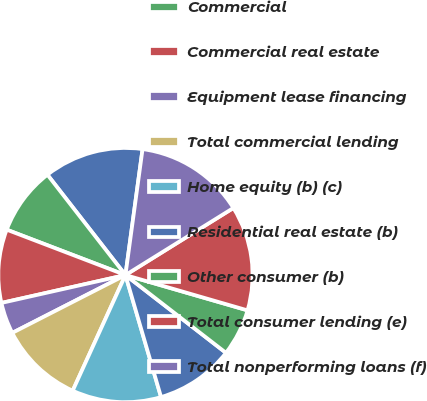Convert chart. <chart><loc_0><loc_0><loc_500><loc_500><pie_chart><fcel>December 31 - dollars in<fcel>Commercial<fcel>Commercial real estate<fcel>Equipment lease financing<fcel>Total commercial lending<fcel>Home equity (b) (c)<fcel>Residential real estate (b)<fcel>Other consumer (b)<fcel>Total consumer lending (e)<fcel>Total nonperforming loans (f)<nl><fcel>12.67%<fcel>8.67%<fcel>9.33%<fcel>4.0%<fcel>10.67%<fcel>11.33%<fcel>10.0%<fcel>6.0%<fcel>13.33%<fcel>14.0%<nl></chart> 